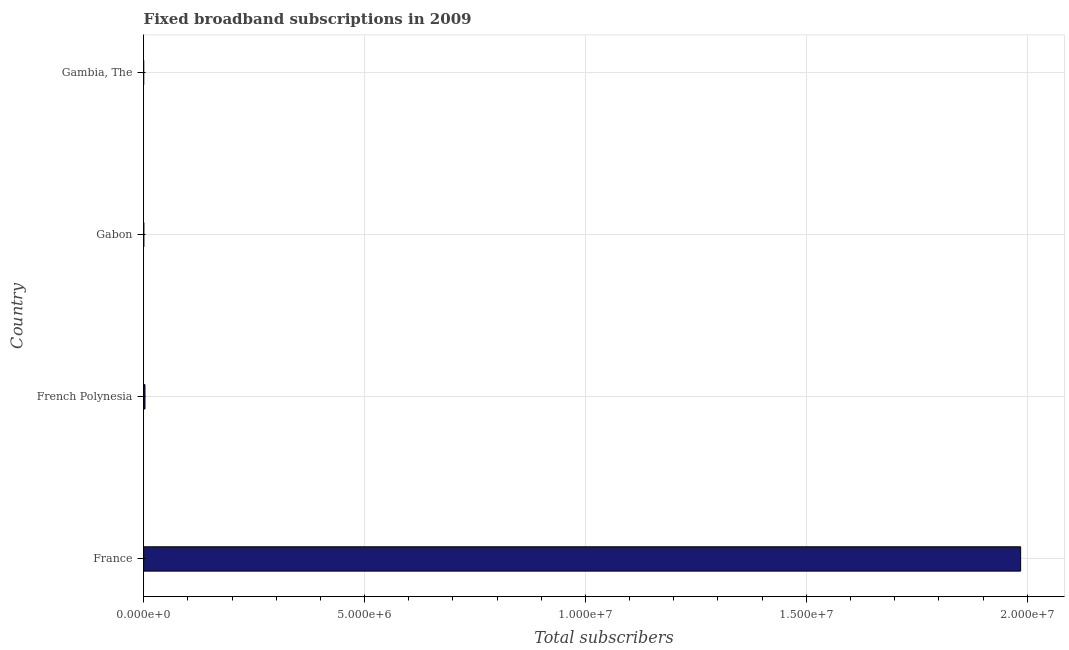Does the graph contain any zero values?
Your answer should be very brief. No. What is the title of the graph?
Provide a succinct answer. Fixed broadband subscriptions in 2009. What is the label or title of the X-axis?
Your response must be concise. Total subscribers. What is the total number of fixed broadband subscriptions in French Polynesia?
Offer a terse response. 3.00e+04. Across all countries, what is the maximum total number of fixed broadband subscriptions?
Keep it short and to the point. 1.99e+07. Across all countries, what is the minimum total number of fixed broadband subscriptions?
Give a very brief answer. 300. In which country was the total number of fixed broadband subscriptions minimum?
Offer a very short reply. Gambia, The. What is the sum of the total number of fixed broadband subscriptions?
Provide a succinct answer. 1.99e+07. What is the difference between the total number of fixed broadband subscriptions in Gabon and Gambia, The?
Keep it short and to the point. 3397. What is the average total number of fixed broadband subscriptions per country?
Your response must be concise. 4.97e+06. What is the median total number of fixed broadband subscriptions?
Your answer should be compact. 1.69e+04. In how many countries, is the total number of fixed broadband subscriptions greater than 14000000 ?
Give a very brief answer. 1. What is the ratio of the total number of fixed broadband subscriptions in Gabon to that in Gambia, The?
Provide a succinct answer. 12.32. What is the difference between the highest and the second highest total number of fixed broadband subscriptions?
Your answer should be very brief. 1.98e+07. What is the difference between the highest and the lowest total number of fixed broadband subscriptions?
Make the answer very short. 1.99e+07. In how many countries, is the total number of fixed broadband subscriptions greater than the average total number of fixed broadband subscriptions taken over all countries?
Your response must be concise. 1. Are all the bars in the graph horizontal?
Your response must be concise. Yes. What is the difference between two consecutive major ticks on the X-axis?
Keep it short and to the point. 5.00e+06. What is the Total subscribers in France?
Offer a very short reply. 1.99e+07. What is the Total subscribers in French Polynesia?
Give a very brief answer. 3.00e+04. What is the Total subscribers of Gabon?
Give a very brief answer. 3697. What is the Total subscribers in Gambia, The?
Give a very brief answer. 300. What is the difference between the Total subscribers in France and French Polynesia?
Your response must be concise. 1.98e+07. What is the difference between the Total subscribers in France and Gabon?
Your response must be concise. 1.98e+07. What is the difference between the Total subscribers in France and Gambia, The?
Offer a terse response. 1.99e+07. What is the difference between the Total subscribers in French Polynesia and Gabon?
Ensure brevity in your answer.  2.63e+04. What is the difference between the Total subscribers in French Polynesia and Gambia, The?
Give a very brief answer. 2.97e+04. What is the difference between the Total subscribers in Gabon and Gambia, The?
Provide a short and direct response. 3397. What is the ratio of the Total subscribers in France to that in French Polynesia?
Offer a very short reply. 661.07. What is the ratio of the Total subscribers in France to that in Gabon?
Make the answer very short. 5369.76. What is the ratio of the Total subscribers in France to that in Gambia, The?
Your response must be concise. 6.62e+04. What is the ratio of the Total subscribers in French Polynesia to that in Gabon?
Keep it short and to the point. 8.12. What is the ratio of the Total subscribers in French Polynesia to that in Gambia, The?
Offer a very short reply. 100.1. What is the ratio of the Total subscribers in Gabon to that in Gambia, The?
Make the answer very short. 12.32. 